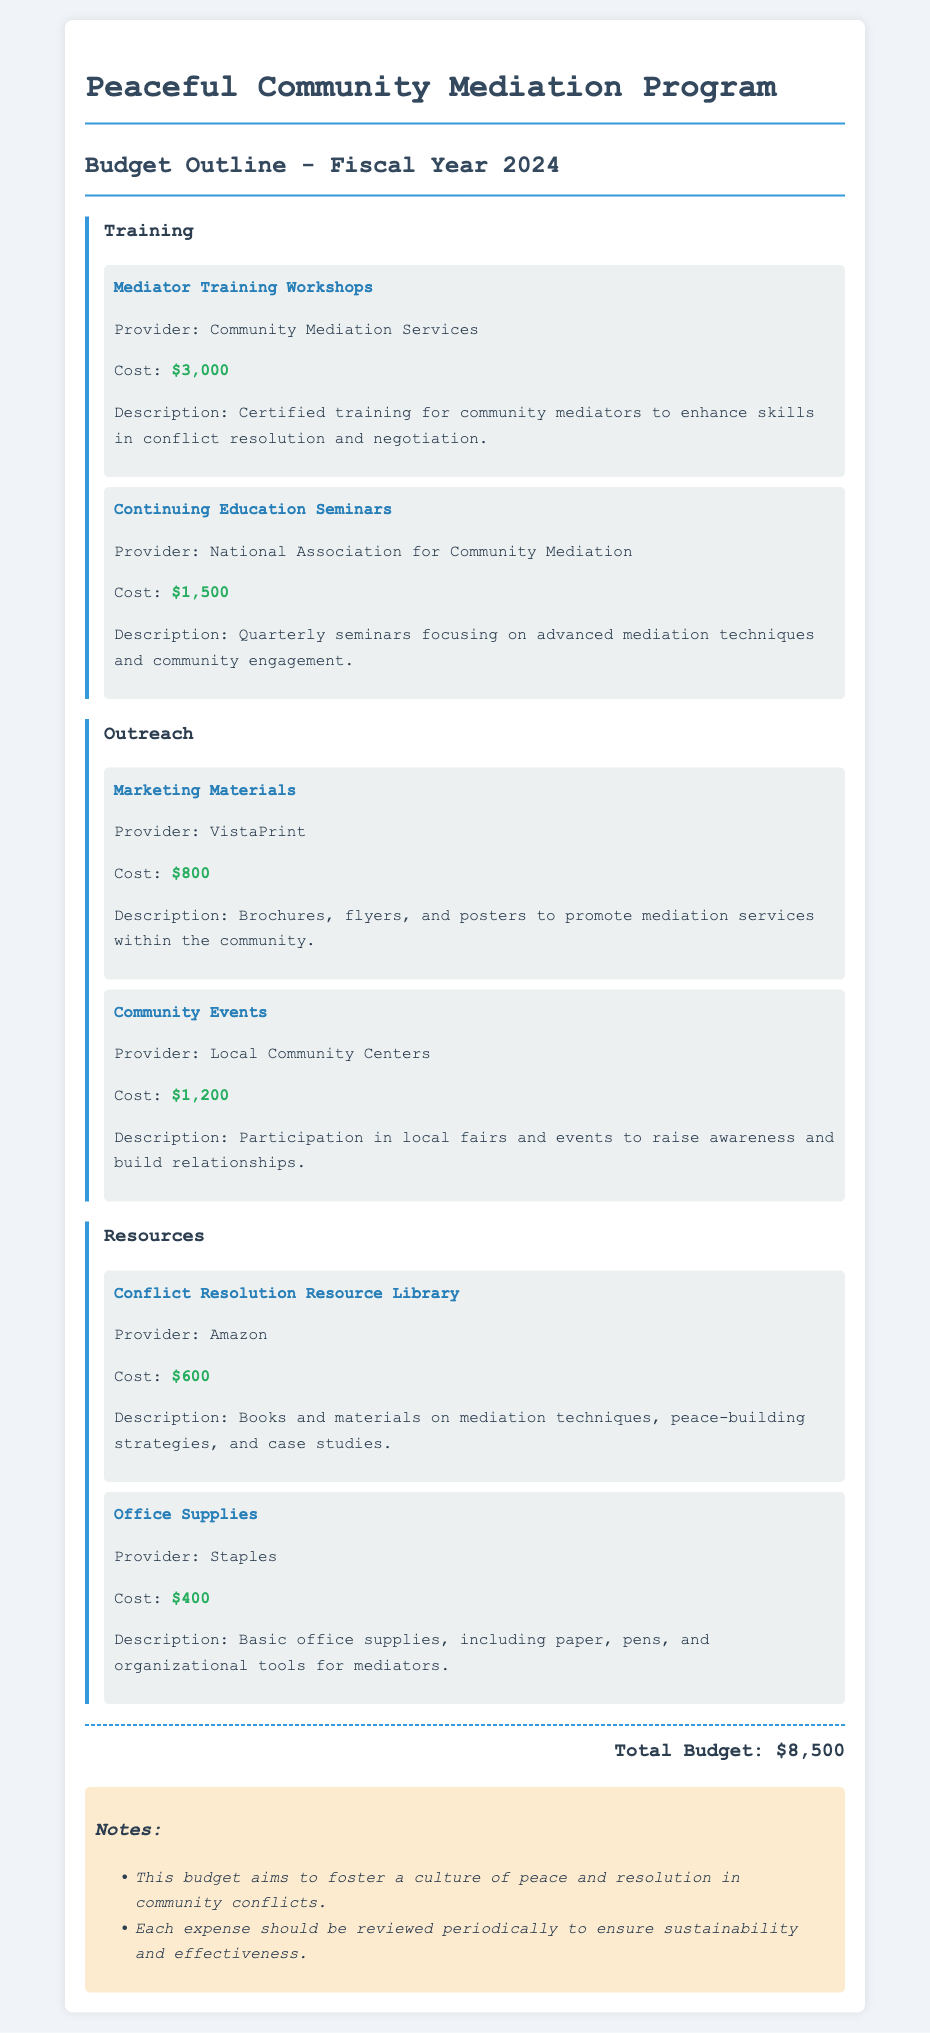what is the total budget? The total budget is calculated as the sum of all anticipated expenses in the document.
Answer: $8,500 how much does the Mediator Training Workshops cost? The cost for the Mediator Training Workshops is specified in the training section of the document.
Answer: $3,000 what type of materials are included in Marketing Materials? The Marketing Materials include brochures, flyers, and posters as described in the outreach section.
Answer: brochures, flyers, and posters who provides the Continuing Education Seminars? The provider for the Continuing Education Seminars is mentioned in the training category of the budget.
Answer: National Association for Community Mediation how many community events are planned? The budget mentions participation in local fairs and events to raise awareness, indicating multiple events but does not specify a number.
Answer: Not specified what is included in the Conflict Resolution Resource Library? The resources in the library are described as books and materials on mediation techniques and peace-building strategies.
Answer: books and materials on mediation techniques and peace-building strategies what is the purpose of the budget? The purpose is outlined in the notes section of the document to foster a culture of peace and resolution.
Answer: to foster a culture of peace and resolution when is the budget for? The fiscal year for the budget is mentioned at the beginning of the document.
Answer: Fiscal Year 2024 